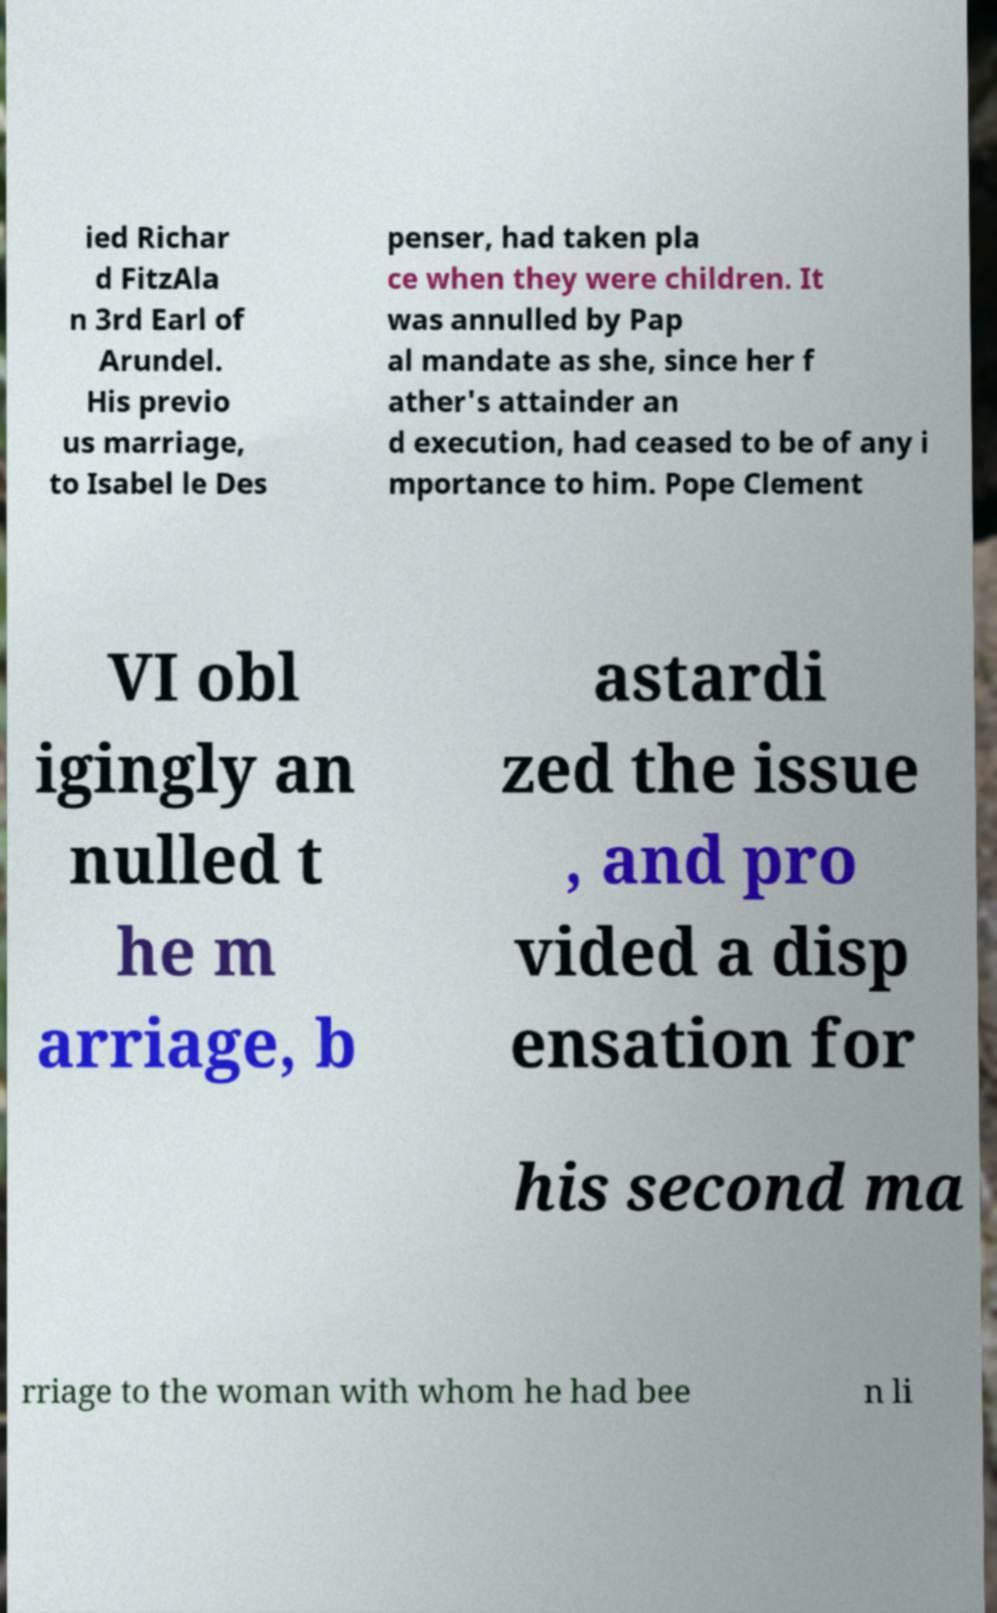What messages or text are displayed in this image? I need them in a readable, typed format. ied Richar d FitzAla n 3rd Earl of Arundel. His previo us marriage, to Isabel le Des penser, had taken pla ce when they were children. It was annulled by Pap al mandate as she, since her f ather's attainder an d execution, had ceased to be of any i mportance to him. Pope Clement VI obl igingly an nulled t he m arriage, b astardi zed the issue , and pro vided a disp ensation for his second ma rriage to the woman with whom he had bee n li 